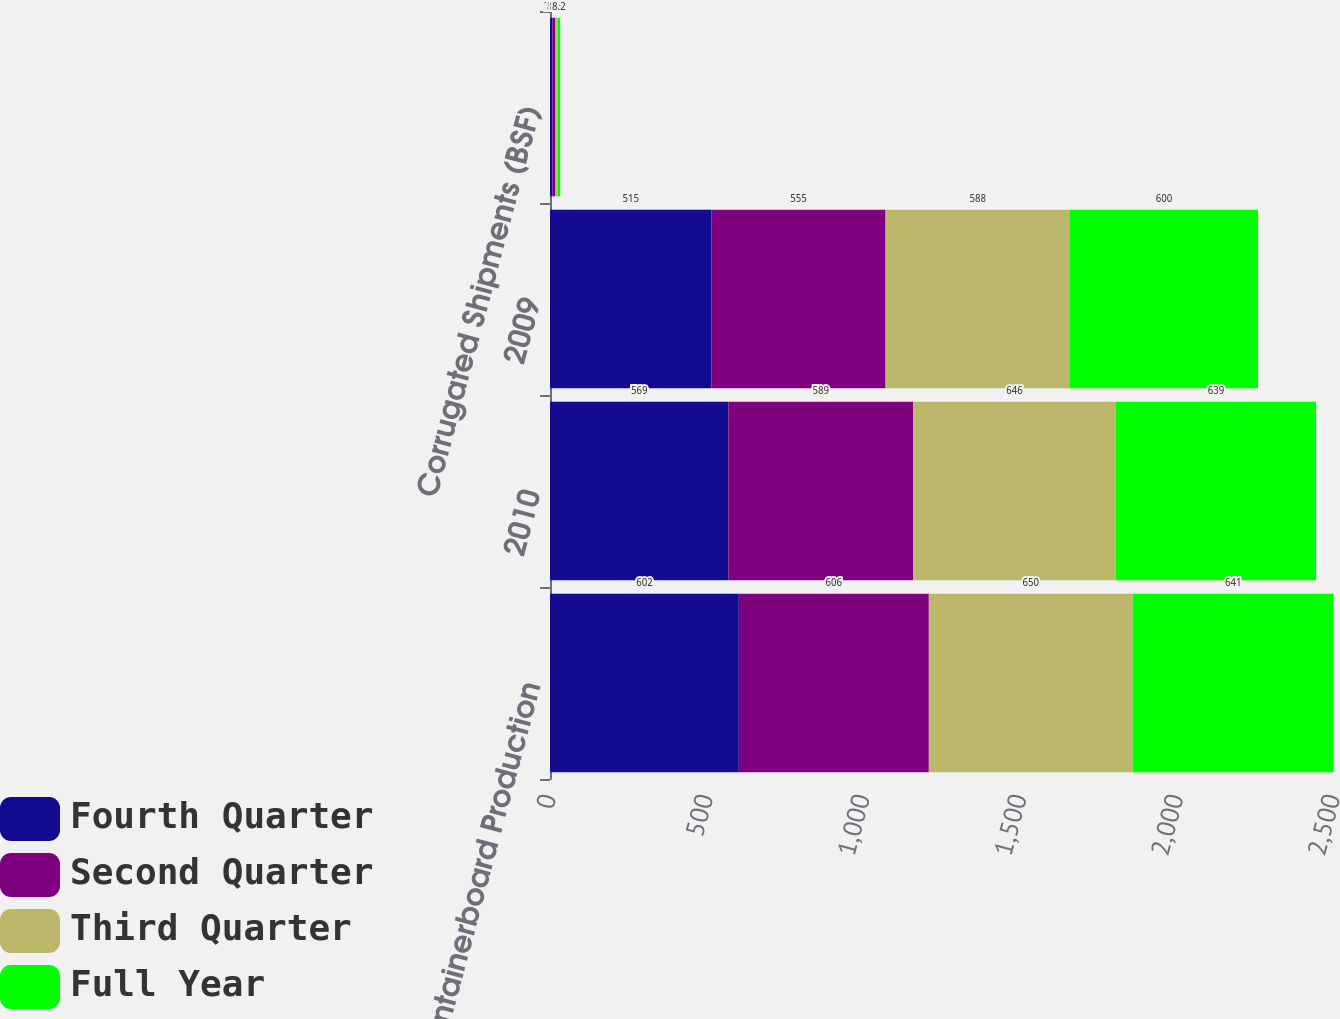<chart> <loc_0><loc_0><loc_500><loc_500><stacked_bar_chart><ecel><fcel>Containerboard Production<fcel>2010<fcel>2009<fcel>Corrugated Shipments (BSF)<nl><fcel>Fourth Quarter<fcel>602<fcel>569<fcel>515<fcel>7.8<nl><fcel>Second Quarter<fcel>606<fcel>589<fcel>555<fcel>8.2<nl><fcel>Third Quarter<fcel>650<fcel>646<fcel>588<fcel>8.3<nl><fcel>Full Year<fcel>641<fcel>639<fcel>600<fcel>8.2<nl></chart> 